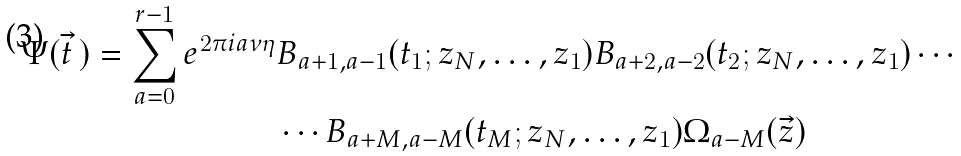Convert formula to latex. <formula><loc_0><loc_0><loc_500><loc_500>\Psi ( \vec { t } \, ) = \sum _ { a = 0 } ^ { r - 1 } e ^ { 2 \pi i a \nu \eta } & B _ { a + 1 , a - 1 } ( t _ { 1 } ; z _ { N } , \dots , z _ { 1 } ) B _ { a + 2 , a - 2 } ( t _ { 2 } ; z _ { N } , \dots , z _ { 1 } ) \cdots \\ & \cdots B _ { a + M , a - M } ( t _ { M } ; z _ { N } , \dots , z _ { 1 } ) \Omega _ { a - M } ( \vec { z } )</formula> 